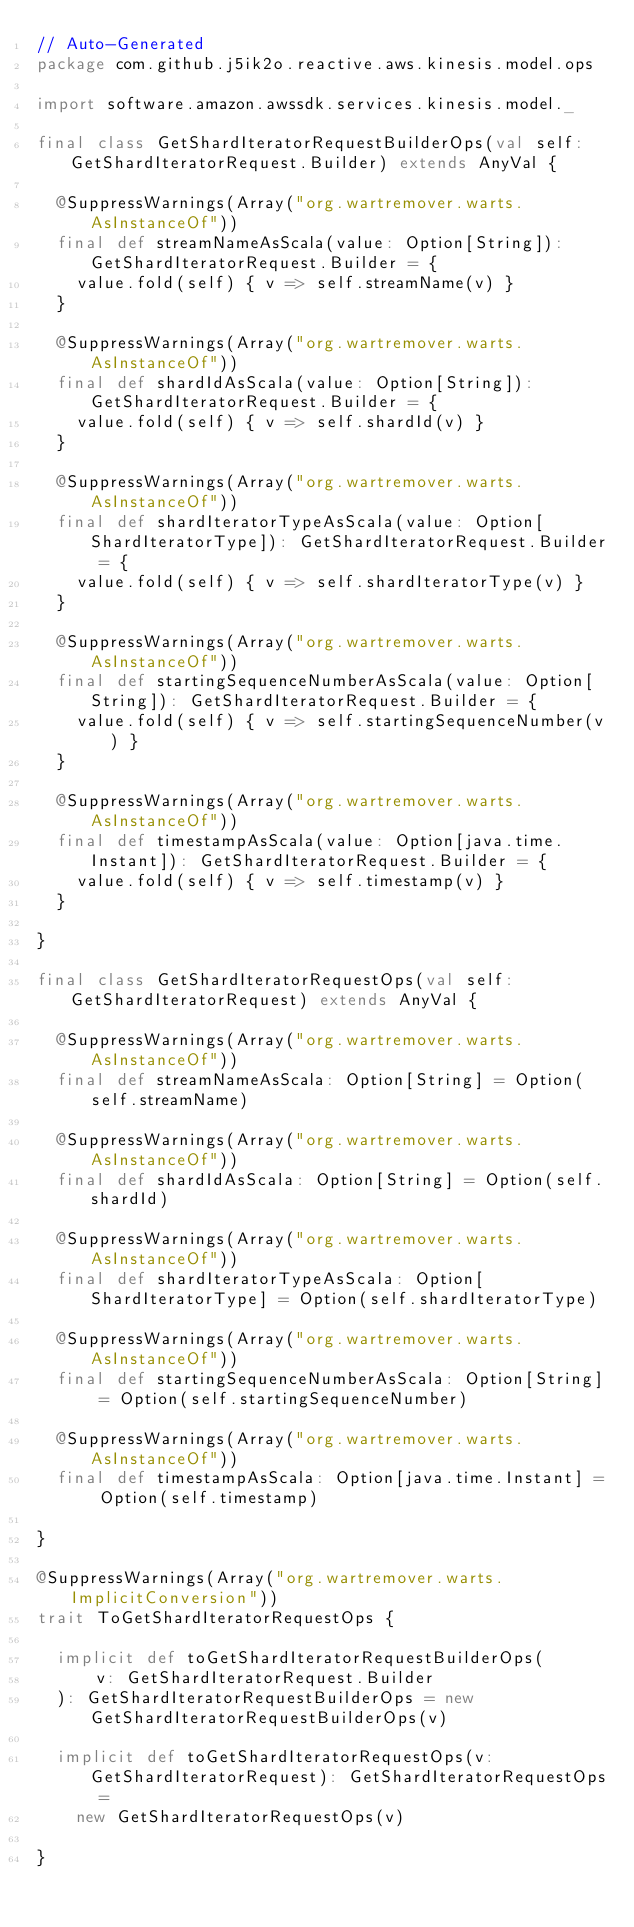<code> <loc_0><loc_0><loc_500><loc_500><_Scala_>// Auto-Generated
package com.github.j5ik2o.reactive.aws.kinesis.model.ops

import software.amazon.awssdk.services.kinesis.model._

final class GetShardIteratorRequestBuilderOps(val self: GetShardIteratorRequest.Builder) extends AnyVal {

  @SuppressWarnings(Array("org.wartremover.warts.AsInstanceOf"))
  final def streamNameAsScala(value: Option[String]): GetShardIteratorRequest.Builder = {
    value.fold(self) { v => self.streamName(v) }
  }

  @SuppressWarnings(Array("org.wartremover.warts.AsInstanceOf"))
  final def shardIdAsScala(value: Option[String]): GetShardIteratorRequest.Builder = {
    value.fold(self) { v => self.shardId(v) }
  }

  @SuppressWarnings(Array("org.wartremover.warts.AsInstanceOf"))
  final def shardIteratorTypeAsScala(value: Option[ShardIteratorType]): GetShardIteratorRequest.Builder = {
    value.fold(self) { v => self.shardIteratorType(v) }
  }

  @SuppressWarnings(Array("org.wartremover.warts.AsInstanceOf"))
  final def startingSequenceNumberAsScala(value: Option[String]): GetShardIteratorRequest.Builder = {
    value.fold(self) { v => self.startingSequenceNumber(v) }
  }

  @SuppressWarnings(Array("org.wartremover.warts.AsInstanceOf"))
  final def timestampAsScala(value: Option[java.time.Instant]): GetShardIteratorRequest.Builder = {
    value.fold(self) { v => self.timestamp(v) }
  }

}

final class GetShardIteratorRequestOps(val self: GetShardIteratorRequest) extends AnyVal {

  @SuppressWarnings(Array("org.wartremover.warts.AsInstanceOf"))
  final def streamNameAsScala: Option[String] = Option(self.streamName)

  @SuppressWarnings(Array("org.wartremover.warts.AsInstanceOf"))
  final def shardIdAsScala: Option[String] = Option(self.shardId)

  @SuppressWarnings(Array("org.wartremover.warts.AsInstanceOf"))
  final def shardIteratorTypeAsScala: Option[ShardIteratorType] = Option(self.shardIteratorType)

  @SuppressWarnings(Array("org.wartremover.warts.AsInstanceOf"))
  final def startingSequenceNumberAsScala: Option[String] = Option(self.startingSequenceNumber)

  @SuppressWarnings(Array("org.wartremover.warts.AsInstanceOf"))
  final def timestampAsScala: Option[java.time.Instant] = Option(self.timestamp)

}

@SuppressWarnings(Array("org.wartremover.warts.ImplicitConversion"))
trait ToGetShardIteratorRequestOps {

  implicit def toGetShardIteratorRequestBuilderOps(
      v: GetShardIteratorRequest.Builder
  ): GetShardIteratorRequestBuilderOps = new GetShardIteratorRequestBuilderOps(v)

  implicit def toGetShardIteratorRequestOps(v: GetShardIteratorRequest): GetShardIteratorRequestOps =
    new GetShardIteratorRequestOps(v)

}
</code> 